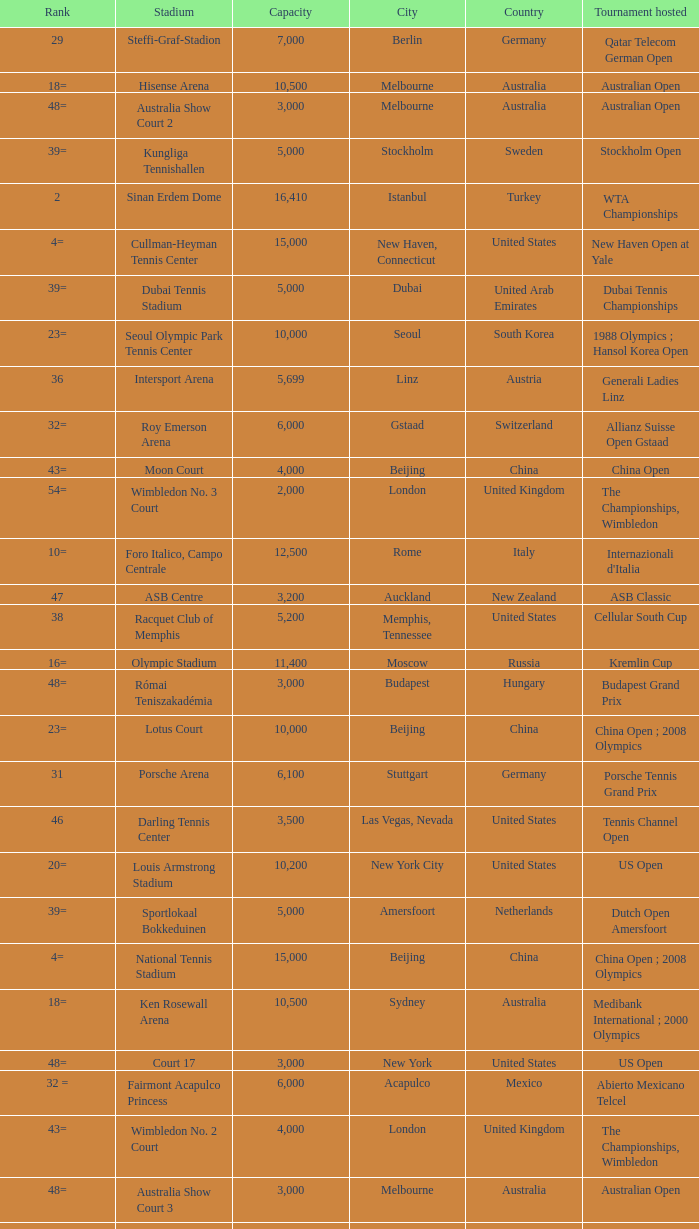What is the average capacity that has switzerland as the country? 6000.0. 